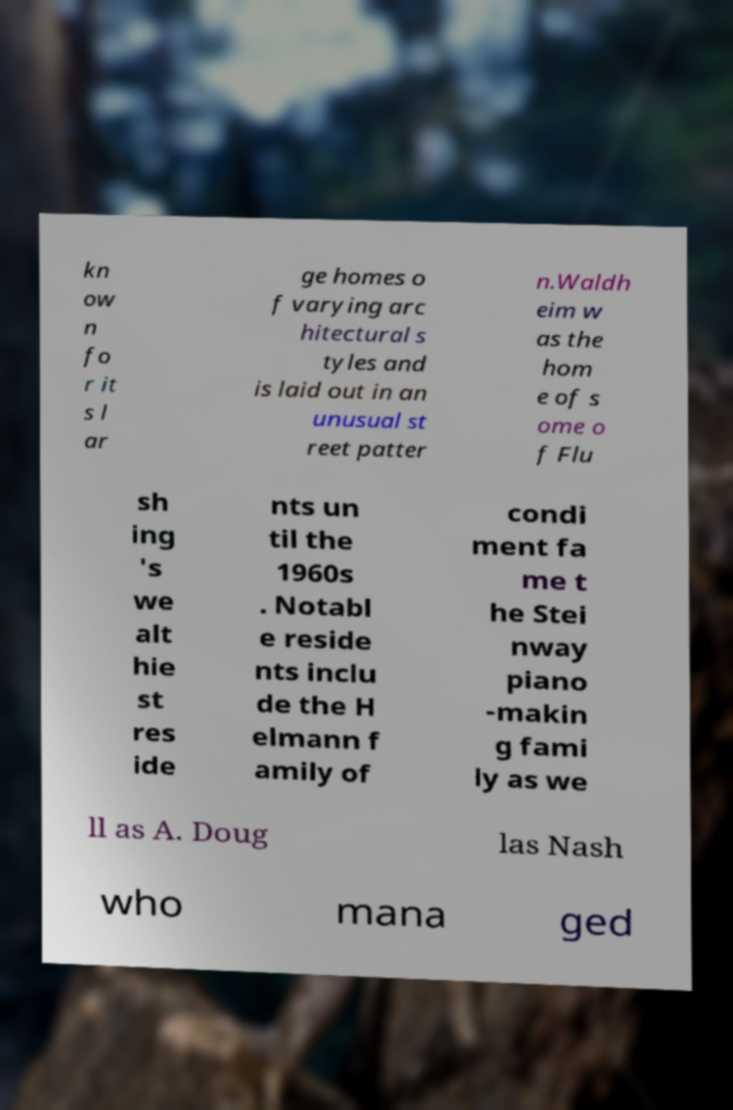What messages or text are displayed in this image? I need them in a readable, typed format. kn ow n fo r it s l ar ge homes o f varying arc hitectural s tyles and is laid out in an unusual st reet patter n.Waldh eim w as the hom e of s ome o f Flu sh ing 's we alt hie st res ide nts un til the 1960s . Notabl e reside nts inclu de the H elmann f amily of condi ment fa me t he Stei nway piano -makin g fami ly as we ll as A. Doug las Nash who mana ged 